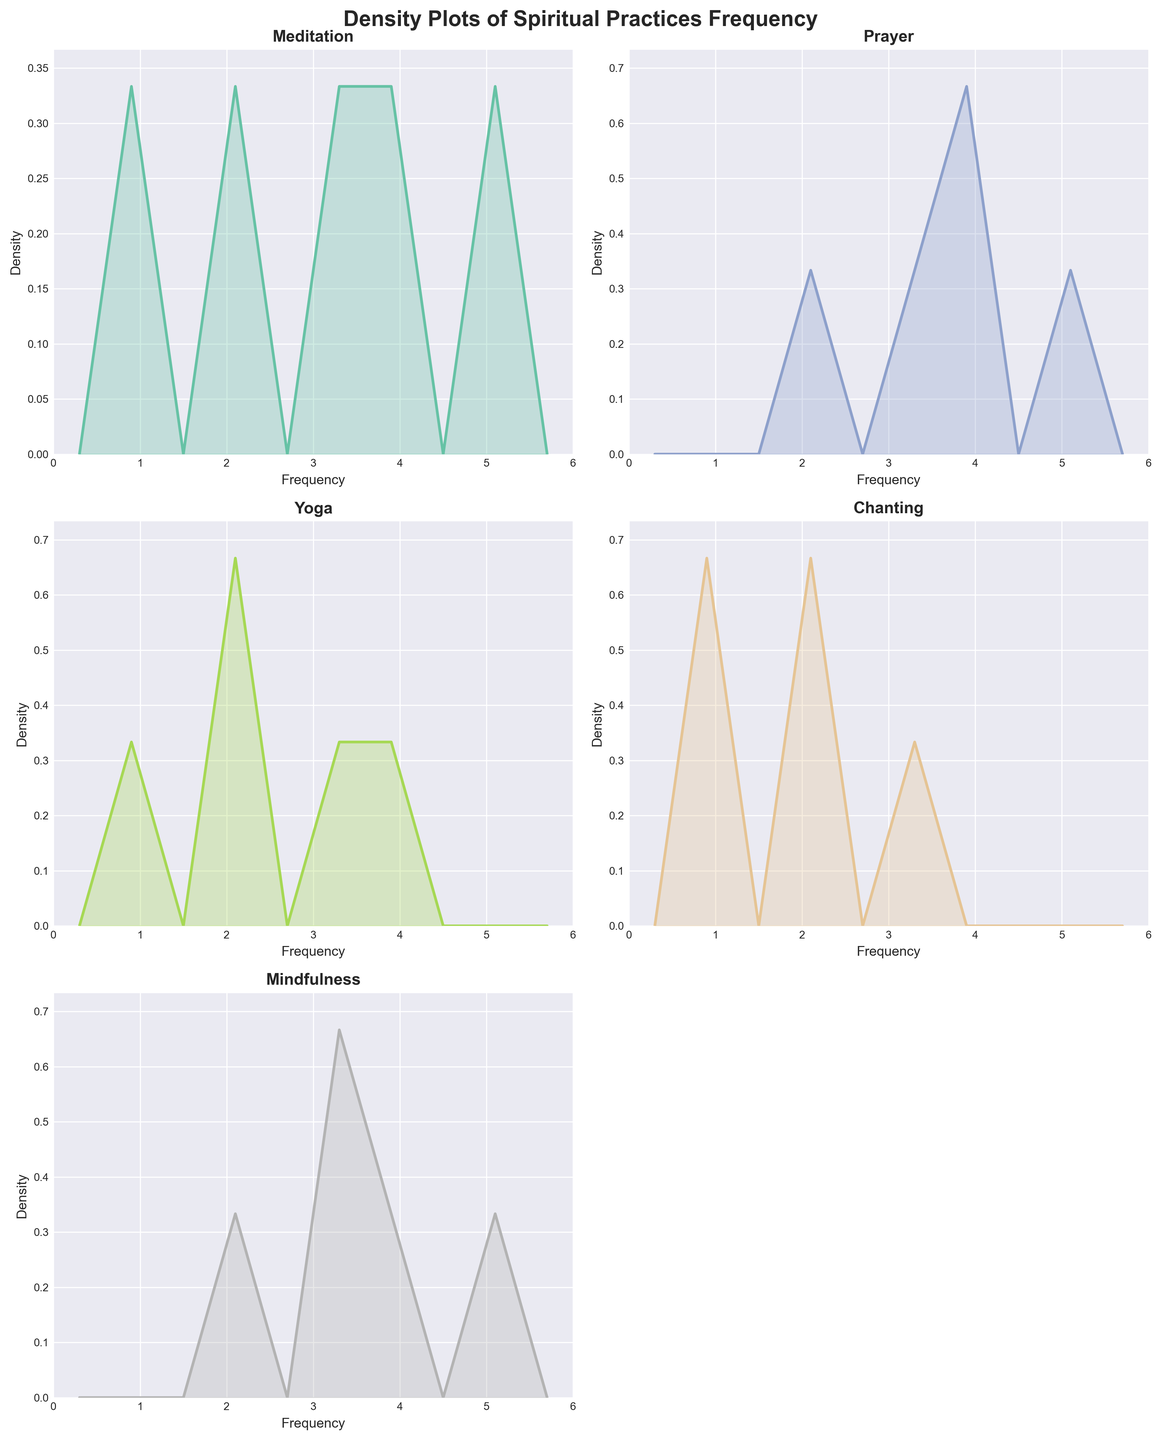How many spiritual practice types are analyzed in the figure? To determine the number of spiritual practice types, look at the titles of each subplot in the figure. There are “Meditation,” “Prayer,” “Yoga,” “Chanting,” and “Mindfulness,” totaling five practice types.
Answer: Five What is the title of the entire figure? The title of the figure is located at the top and is often in larger and bold font. It reads, “Density Plots of Spiritual Practices Frequency.”
Answer: Density Plots of Spiritual Practices Frequency Which spiritual practice has the highest density peak in the frequency range? By examining the peaks of each subplot, we can identify that the "Prayer" density plot has the tallest peak, indicating the highest density.
Answer: Prayer Is the density distribution of "Meditation" more spread out or concentrated compared to "Chanting"? By looking at the width of the density curves, we can observe that the "Meditation" curve is spread across a wider range, while the "Chanting" curve is more narrow and concentrated around lower frequencies.
Answer: More spread out What frequency value has the highest density in the "Mindfulness" plot? Examine the "Mindfulness" subplot and identify the frequency value at the peak of the density curve. The highest peak is at the frequency of 3.
Answer: 3 How does the density distribution for "Yoga" compare to "Meditation"? By comparing the density plots directly, it is clear that "Yoga" has a relatively varied distribution with some concentration in the middle range, while "Meditation" is spread more evenly but without a specific high peak concentration.
Answer: More varied in middle range Which practices show a density peak around the frequency value of 4? Look at the density curves closely for each practice type to see around which frequency the peaks appear. "Prayer" and "Mindfulness" have peaks around the frequency value of 4.
Answer: "Prayer" and "Mindfulness" Does "Chanting" show any density peak at the frequency of 3? By evaluating the density plot for "Chanting," it can be observed that there is a peak around the frequency of 3.
Answer: Yes What’s the minimum and maximum frequency range displayed in all subplots? Observing the x-axis values of the density plots, the frequency ranges from a minimum of 0 to a maximum of 6.
Answer: 0 to 6 Which spiritual practice has the most evenly distributed density spread? By comparing all density plots, the “Meditation” plot appears the most evenly spread as it does not have very high peaks and the density is relatively uniform across the frequency range.
Answer: Meditation 